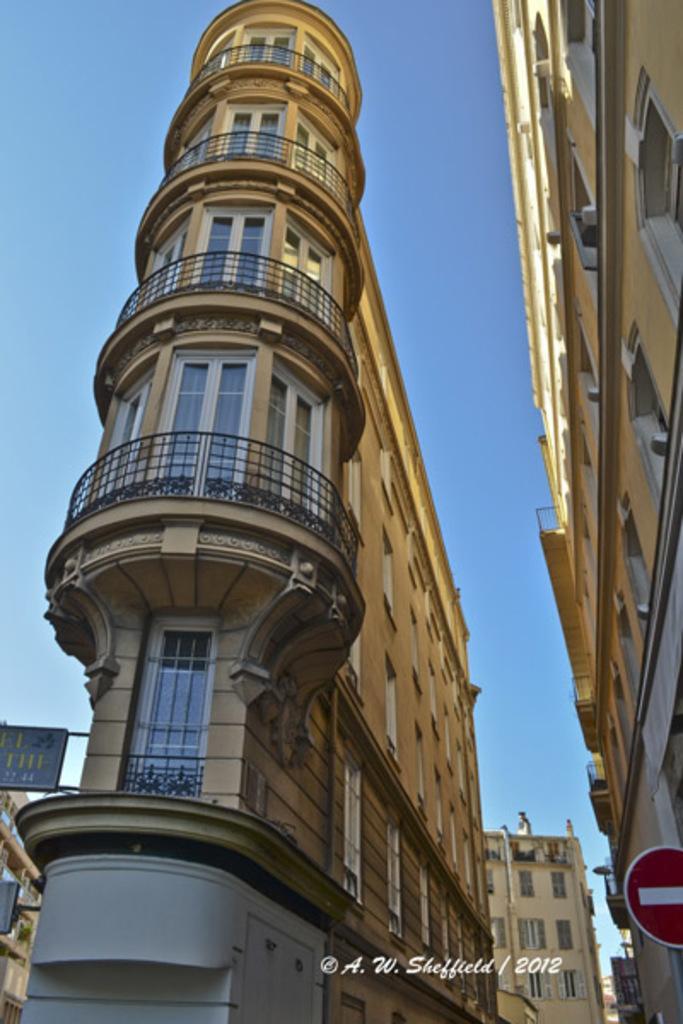How would you summarize this image in a sentence or two? In the middle of the picture, we see a five storey building. It has windows and railings. On the right side, we see a building and a red color board. There are buildings in the background. At the top of the picture, we see the sky, which is blue in color. 